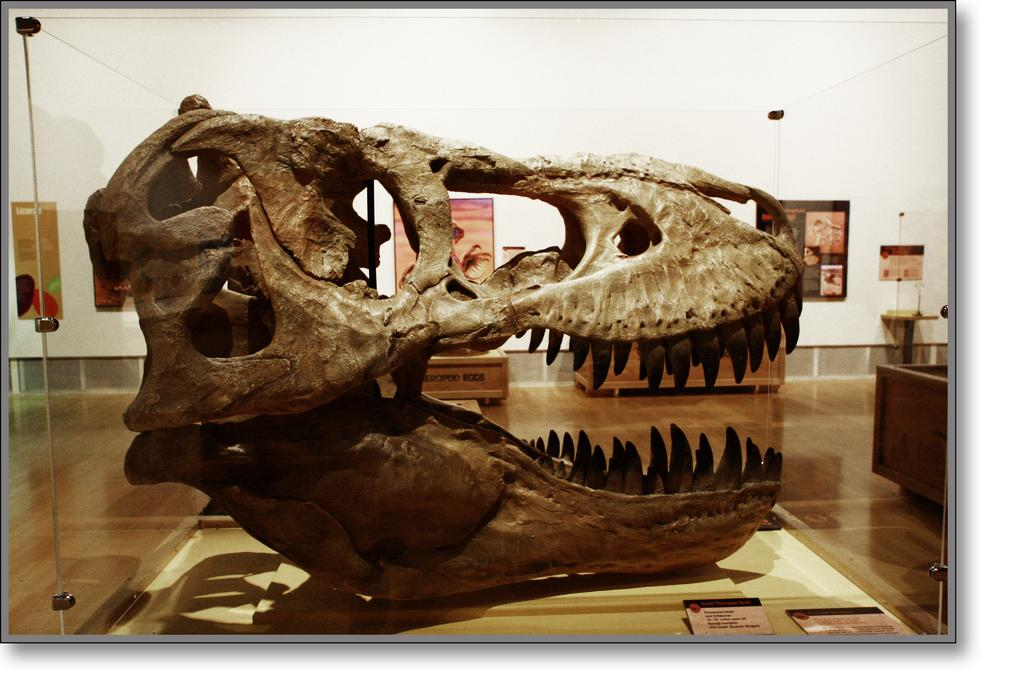What is the main subject of the image? The main subject of the image is a dinosaur skull in a glass box. What can be seen in the background of the image? There are frames attached to the wall in the background of the image. What color is the wall in the image? The wall is white in color. Can you tell me how many poisonous creatures are swimming in the ocean in the image? There is no ocean or poisonous creatures present in the image; it features a dinosaur skull in a glass box and frames on a white wall. 